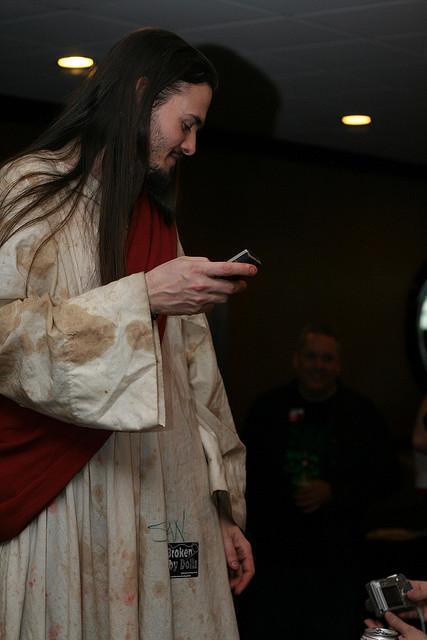How many people can you see?
Give a very brief answer. 2. 